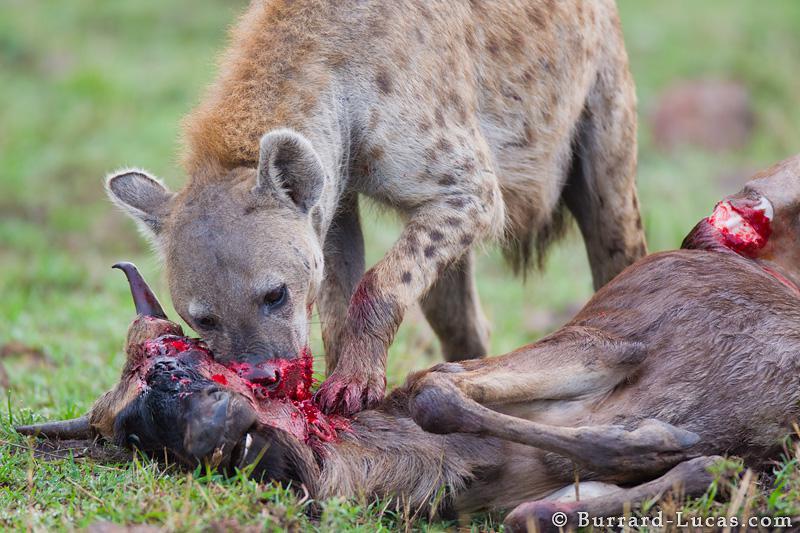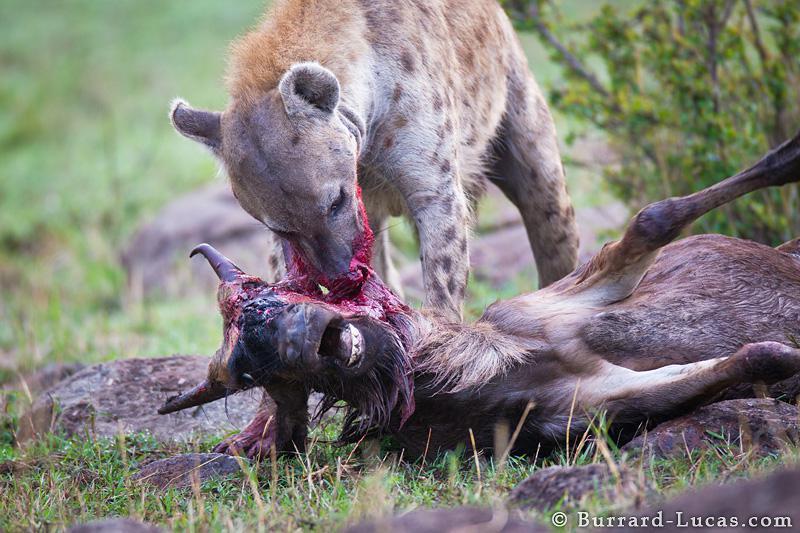The first image is the image on the left, the second image is the image on the right. Considering the images on both sides, is "Both images in the pair show two or more hyenas feasting a recent kill." valid? Answer yes or no. No. 